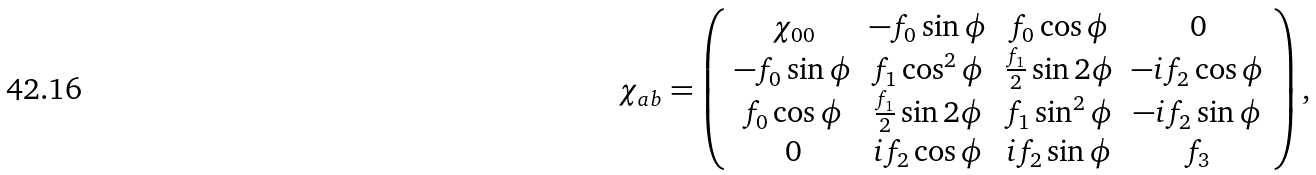<formula> <loc_0><loc_0><loc_500><loc_500>\chi _ { a b } = \left ( \begin{array} { c c c c } \chi _ { 0 0 } & - f _ { 0 } \sin \phi & f _ { 0 } \cos \phi & 0 \\ - f _ { 0 } \sin \phi & f _ { 1 } \cos ^ { 2 } \phi & \frac { f _ { 1 } } { 2 } \sin 2 \phi & - i f _ { 2 } \cos \phi \\ f _ { 0 } \cos \phi & \frac { f _ { 1 } } { 2 } \sin 2 \phi & f _ { 1 } \sin ^ { 2 } \phi & - i f _ { 2 } \sin \phi \\ 0 & i f _ { 2 } \cos \phi & i f _ { 2 } \sin \phi & f _ { 3 } \end{array} \right ) ,</formula> 